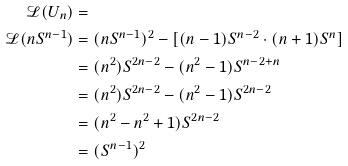<formula> <loc_0><loc_0><loc_500><loc_500>\mathcal { L } ( U _ { n } ) & = \\ \mathcal { L } ( n S ^ { n - 1 } ) & = ( n S ^ { n - 1 } ) ^ { 2 } - [ ( n - 1 ) S ^ { n - 2 } \cdot ( n + 1 ) S ^ { n } ] \\ & = ( n ^ { 2 } ) S ^ { 2 n - 2 } - ( n ^ { 2 } - 1 ) S ^ { n - 2 + n } \\ & = ( n ^ { 2 } ) S ^ { 2 n - 2 } - ( n ^ { 2 } - 1 ) S ^ { 2 n - 2 } \\ & = ( n ^ { 2 } - n ^ { 2 } + 1 ) S ^ { 2 n - 2 } \\ & = ( S ^ { n - 1 } ) ^ { 2 }</formula> 